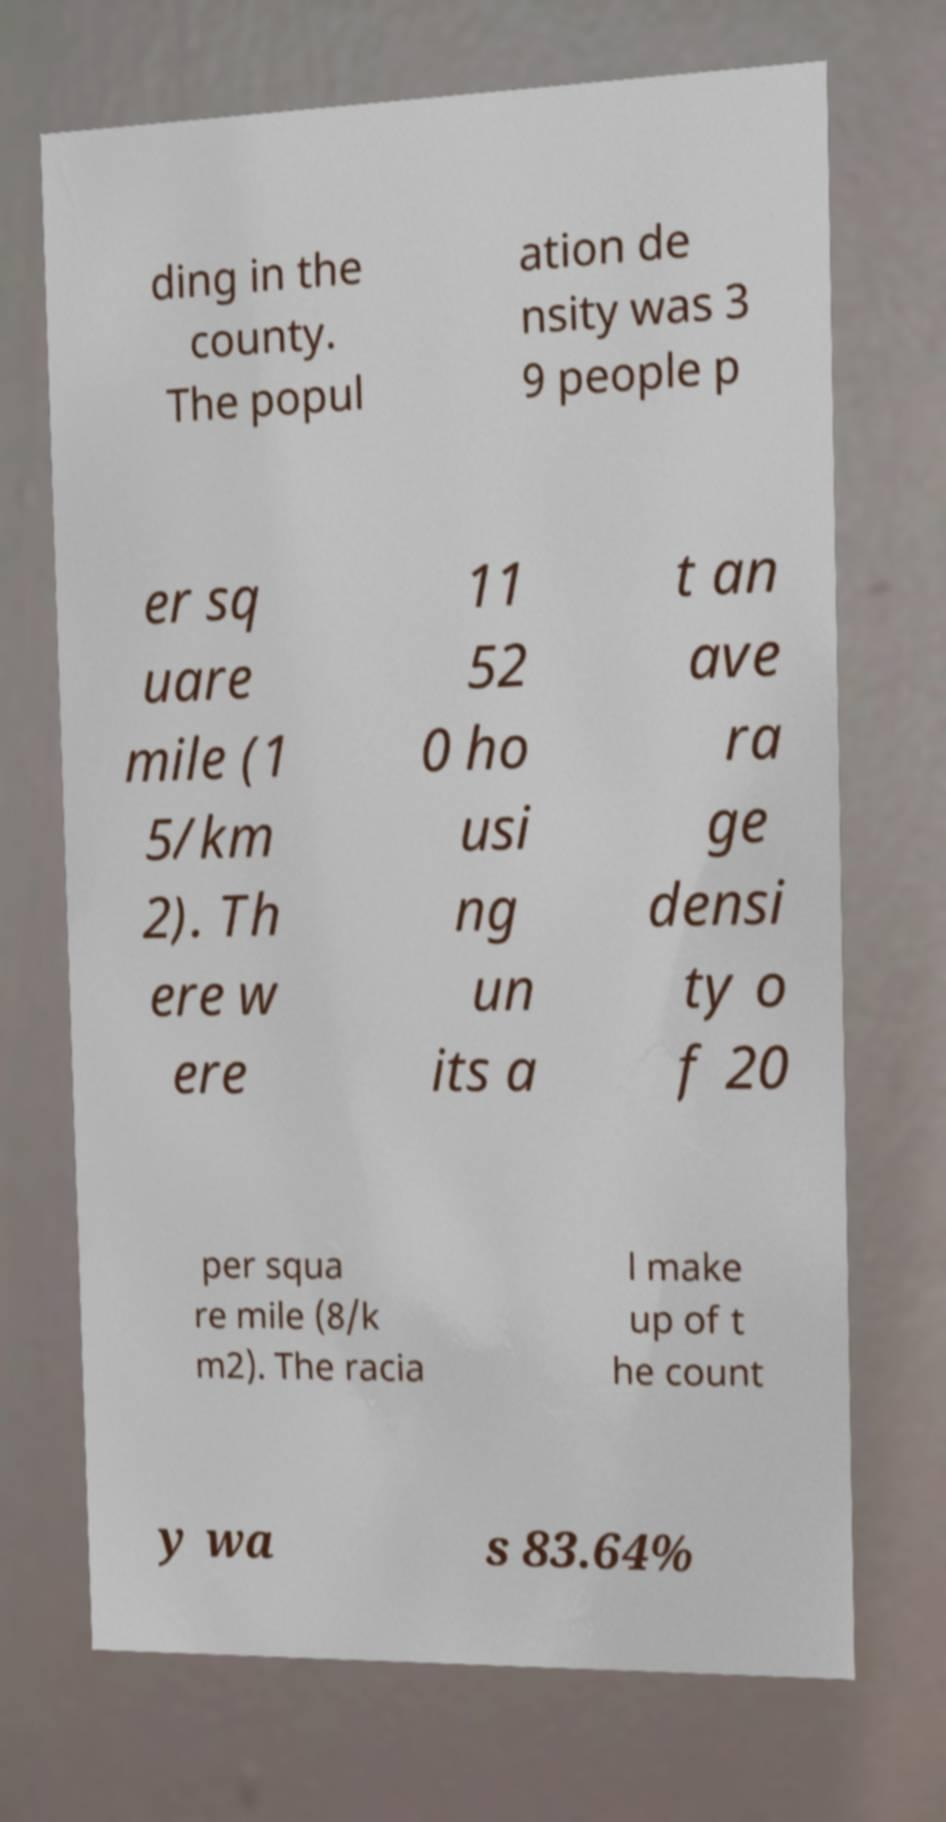Please identify and transcribe the text found in this image. ding in the county. The popul ation de nsity was 3 9 people p er sq uare mile (1 5/km 2). Th ere w ere 11 52 0 ho usi ng un its a t an ave ra ge densi ty o f 20 per squa re mile (8/k m2). The racia l make up of t he count y wa s 83.64% 